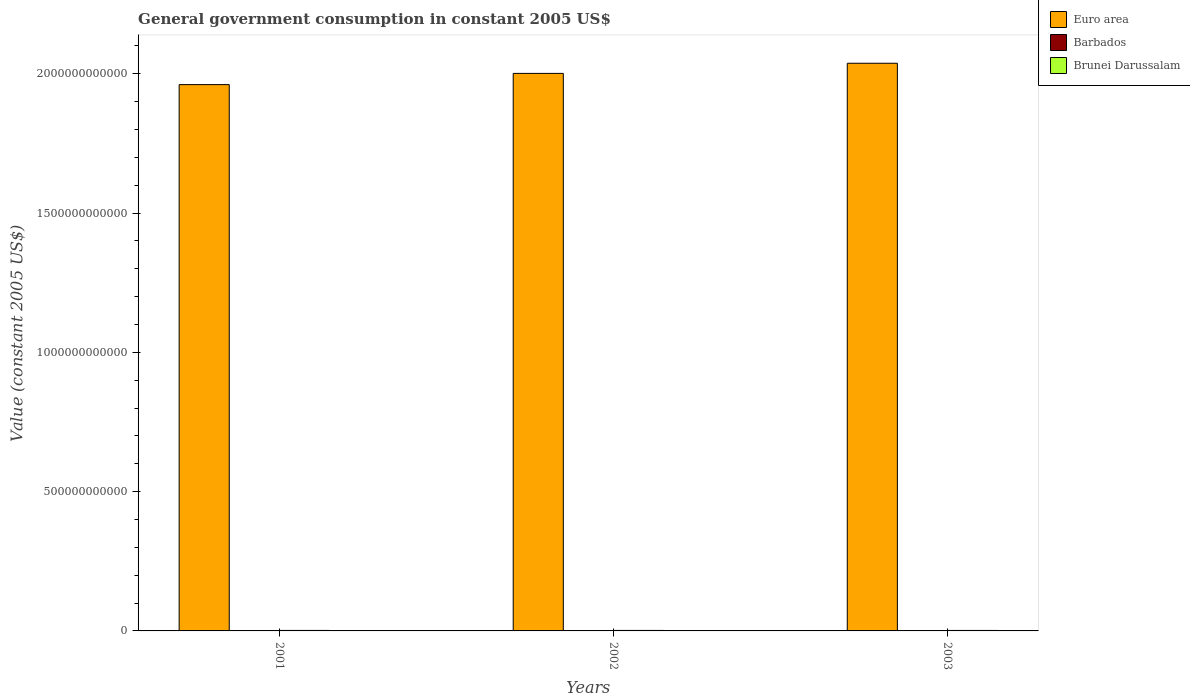How many different coloured bars are there?
Provide a short and direct response. 3. How many groups of bars are there?
Give a very brief answer. 3. How many bars are there on the 3rd tick from the right?
Provide a succinct answer. 3. In how many cases, is the number of bars for a given year not equal to the number of legend labels?
Your answer should be very brief. 0. What is the government conusmption in Brunei Darussalam in 2001?
Make the answer very short. 1.78e+09. Across all years, what is the maximum government conusmption in Barbados?
Ensure brevity in your answer.  6.67e+08. Across all years, what is the minimum government conusmption in Barbados?
Offer a very short reply. 4.63e+08. In which year was the government conusmption in Euro area maximum?
Your answer should be very brief. 2003. What is the total government conusmption in Barbados in the graph?
Your answer should be compact. 1.63e+09. What is the difference between the government conusmption in Euro area in 2001 and that in 2002?
Ensure brevity in your answer.  -4.02e+1. What is the difference between the government conusmption in Barbados in 2003 and the government conusmption in Brunei Darussalam in 2001?
Provide a succinct answer. -1.12e+09. What is the average government conusmption in Brunei Darussalam per year?
Ensure brevity in your answer.  1.74e+09. In the year 2001, what is the difference between the government conusmption in Brunei Darussalam and government conusmption in Euro area?
Give a very brief answer. -1.96e+12. What is the ratio of the government conusmption in Euro area in 2001 to that in 2002?
Your answer should be very brief. 0.98. Is the government conusmption in Barbados in 2001 less than that in 2003?
Give a very brief answer. Yes. What is the difference between the highest and the second highest government conusmption in Barbados?
Ensure brevity in your answer.  1.70e+08. What is the difference between the highest and the lowest government conusmption in Brunei Darussalam?
Offer a terse response. 8.04e+07. Is the sum of the government conusmption in Euro area in 2001 and 2002 greater than the maximum government conusmption in Brunei Darussalam across all years?
Provide a short and direct response. Yes. What does the 2nd bar from the left in 2002 represents?
Your answer should be compact. Barbados. What does the 2nd bar from the right in 2003 represents?
Offer a terse response. Barbados. Is it the case that in every year, the sum of the government conusmption in Euro area and government conusmption in Barbados is greater than the government conusmption in Brunei Darussalam?
Keep it short and to the point. Yes. How many bars are there?
Offer a very short reply. 9. Are all the bars in the graph horizontal?
Give a very brief answer. No. How many years are there in the graph?
Ensure brevity in your answer.  3. What is the difference between two consecutive major ticks on the Y-axis?
Your answer should be very brief. 5.00e+11. Are the values on the major ticks of Y-axis written in scientific E-notation?
Ensure brevity in your answer.  No. Does the graph contain any zero values?
Provide a succinct answer. No. How many legend labels are there?
Give a very brief answer. 3. How are the legend labels stacked?
Your answer should be very brief. Vertical. What is the title of the graph?
Provide a short and direct response. General government consumption in constant 2005 US$. Does "Latvia" appear as one of the legend labels in the graph?
Your response must be concise. No. What is the label or title of the X-axis?
Your response must be concise. Years. What is the label or title of the Y-axis?
Your answer should be compact. Value (constant 2005 US$). What is the Value (constant 2005 US$) in Euro area in 2001?
Ensure brevity in your answer.  1.96e+12. What is the Value (constant 2005 US$) in Barbados in 2001?
Offer a terse response. 4.63e+08. What is the Value (constant 2005 US$) in Brunei Darussalam in 2001?
Provide a short and direct response. 1.78e+09. What is the Value (constant 2005 US$) in Euro area in 2002?
Offer a terse response. 2.00e+12. What is the Value (constant 2005 US$) in Barbados in 2002?
Provide a succinct answer. 4.97e+08. What is the Value (constant 2005 US$) in Brunei Darussalam in 2002?
Keep it short and to the point. 1.75e+09. What is the Value (constant 2005 US$) of Euro area in 2003?
Make the answer very short. 2.04e+12. What is the Value (constant 2005 US$) of Barbados in 2003?
Provide a short and direct response. 6.67e+08. What is the Value (constant 2005 US$) of Brunei Darussalam in 2003?
Provide a short and direct response. 1.70e+09. Across all years, what is the maximum Value (constant 2005 US$) of Euro area?
Provide a short and direct response. 2.04e+12. Across all years, what is the maximum Value (constant 2005 US$) of Barbados?
Your answer should be very brief. 6.67e+08. Across all years, what is the maximum Value (constant 2005 US$) of Brunei Darussalam?
Give a very brief answer. 1.78e+09. Across all years, what is the minimum Value (constant 2005 US$) of Euro area?
Provide a succinct answer. 1.96e+12. Across all years, what is the minimum Value (constant 2005 US$) of Barbados?
Offer a terse response. 4.63e+08. Across all years, what is the minimum Value (constant 2005 US$) in Brunei Darussalam?
Offer a very short reply. 1.70e+09. What is the total Value (constant 2005 US$) in Euro area in the graph?
Your answer should be compact. 6.00e+12. What is the total Value (constant 2005 US$) in Barbados in the graph?
Ensure brevity in your answer.  1.63e+09. What is the total Value (constant 2005 US$) in Brunei Darussalam in the graph?
Offer a terse response. 5.23e+09. What is the difference between the Value (constant 2005 US$) of Euro area in 2001 and that in 2002?
Provide a short and direct response. -4.02e+1. What is the difference between the Value (constant 2005 US$) in Barbados in 2001 and that in 2002?
Provide a short and direct response. -3.41e+07. What is the difference between the Value (constant 2005 US$) of Brunei Darussalam in 2001 and that in 2002?
Your answer should be compact. 3.52e+07. What is the difference between the Value (constant 2005 US$) in Euro area in 2001 and that in 2003?
Keep it short and to the point. -7.67e+1. What is the difference between the Value (constant 2005 US$) of Barbados in 2001 and that in 2003?
Keep it short and to the point. -2.05e+08. What is the difference between the Value (constant 2005 US$) of Brunei Darussalam in 2001 and that in 2003?
Your answer should be compact. 8.04e+07. What is the difference between the Value (constant 2005 US$) in Euro area in 2002 and that in 2003?
Your answer should be very brief. -3.64e+1. What is the difference between the Value (constant 2005 US$) of Barbados in 2002 and that in 2003?
Your answer should be compact. -1.70e+08. What is the difference between the Value (constant 2005 US$) in Brunei Darussalam in 2002 and that in 2003?
Offer a terse response. 4.52e+07. What is the difference between the Value (constant 2005 US$) in Euro area in 2001 and the Value (constant 2005 US$) in Barbados in 2002?
Provide a succinct answer. 1.96e+12. What is the difference between the Value (constant 2005 US$) of Euro area in 2001 and the Value (constant 2005 US$) of Brunei Darussalam in 2002?
Offer a terse response. 1.96e+12. What is the difference between the Value (constant 2005 US$) of Barbados in 2001 and the Value (constant 2005 US$) of Brunei Darussalam in 2002?
Give a very brief answer. -1.29e+09. What is the difference between the Value (constant 2005 US$) in Euro area in 2001 and the Value (constant 2005 US$) in Barbados in 2003?
Keep it short and to the point. 1.96e+12. What is the difference between the Value (constant 2005 US$) in Euro area in 2001 and the Value (constant 2005 US$) in Brunei Darussalam in 2003?
Offer a very short reply. 1.96e+12. What is the difference between the Value (constant 2005 US$) of Barbados in 2001 and the Value (constant 2005 US$) of Brunei Darussalam in 2003?
Provide a short and direct response. -1.24e+09. What is the difference between the Value (constant 2005 US$) in Euro area in 2002 and the Value (constant 2005 US$) in Barbados in 2003?
Provide a short and direct response. 2.00e+12. What is the difference between the Value (constant 2005 US$) of Euro area in 2002 and the Value (constant 2005 US$) of Brunei Darussalam in 2003?
Offer a terse response. 2.00e+12. What is the difference between the Value (constant 2005 US$) in Barbados in 2002 and the Value (constant 2005 US$) in Brunei Darussalam in 2003?
Ensure brevity in your answer.  -1.21e+09. What is the average Value (constant 2005 US$) in Euro area per year?
Offer a terse response. 2.00e+12. What is the average Value (constant 2005 US$) in Barbados per year?
Ensure brevity in your answer.  5.42e+08. What is the average Value (constant 2005 US$) in Brunei Darussalam per year?
Your response must be concise. 1.74e+09. In the year 2001, what is the difference between the Value (constant 2005 US$) in Euro area and Value (constant 2005 US$) in Barbados?
Offer a terse response. 1.96e+12. In the year 2001, what is the difference between the Value (constant 2005 US$) of Euro area and Value (constant 2005 US$) of Brunei Darussalam?
Your answer should be compact. 1.96e+12. In the year 2001, what is the difference between the Value (constant 2005 US$) in Barbados and Value (constant 2005 US$) in Brunei Darussalam?
Offer a terse response. -1.32e+09. In the year 2002, what is the difference between the Value (constant 2005 US$) of Euro area and Value (constant 2005 US$) of Barbados?
Provide a short and direct response. 2.00e+12. In the year 2002, what is the difference between the Value (constant 2005 US$) in Euro area and Value (constant 2005 US$) in Brunei Darussalam?
Ensure brevity in your answer.  2.00e+12. In the year 2002, what is the difference between the Value (constant 2005 US$) in Barbados and Value (constant 2005 US$) in Brunei Darussalam?
Ensure brevity in your answer.  -1.25e+09. In the year 2003, what is the difference between the Value (constant 2005 US$) in Euro area and Value (constant 2005 US$) in Barbados?
Give a very brief answer. 2.04e+12. In the year 2003, what is the difference between the Value (constant 2005 US$) in Euro area and Value (constant 2005 US$) in Brunei Darussalam?
Offer a terse response. 2.04e+12. In the year 2003, what is the difference between the Value (constant 2005 US$) of Barbados and Value (constant 2005 US$) of Brunei Darussalam?
Offer a terse response. -1.04e+09. What is the ratio of the Value (constant 2005 US$) of Euro area in 2001 to that in 2002?
Offer a very short reply. 0.98. What is the ratio of the Value (constant 2005 US$) in Barbados in 2001 to that in 2002?
Your answer should be very brief. 0.93. What is the ratio of the Value (constant 2005 US$) in Brunei Darussalam in 2001 to that in 2002?
Give a very brief answer. 1.02. What is the ratio of the Value (constant 2005 US$) in Euro area in 2001 to that in 2003?
Your answer should be very brief. 0.96. What is the ratio of the Value (constant 2005 US$) of Barbados in 2001 to that in 2003?
Give a very brief answer. 0.69. What is the ratio of the Value (constant 2005 US$) of Brunei Darussalam in 2001 to that in 2003?
Offer a terse response. 1.05. What is the ratio of the Value (constant 2005 US$) in Euro area in 2002 to that in 2003?
Your response must be concise. 0.98. What is the ratio of the Value (constant 2005 US$) of Barbados in 2002 to that in 2003?
Your response must be concise. 0.74. What is the ratio of the Value (constant 2005 US$) in Brunei Darussalam in 2002 to that in 2003?
Keep it short and to the point. 1.03. What is the difference between the highest and the second highest Value (constant 2005 US$) in Euro area?
Your answer should be very brief. 3.64e+1. What is the difference between the highest and the second highest Value (constant 2005 US$) of Barbados?
Give a very brief answer. 1.70e+08. What is the difference between the highest and the second highest Value (constant 2005 US$) in Brunei Darussalam?
Offer a terse response. 3.52e+07. What is the difference between the highest and the lowest Value (constant 2005 US$) in Euro area?
Give a very brief answer. 7.67e+1. What is the difference between the highest and the lowest Value (constant 2005 US$) of Barbados?
Give a very brief answer. 2.05e+08. What is the difference between the highest and the lowest Value (constant 2005 US$) in Brunei Darussalam?
Provide a succinct answer. 8.04e+07. 